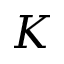<formula> <loc_0><loc_0><loc_500><loc_500>K</formula> 